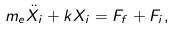<formula> <loc_0><loc_0><loc_500><loc_500>m _ { e } \ddot { X _ { i } } + k X _ { i } = F _ { f } + F _ { i } ,</formula> 